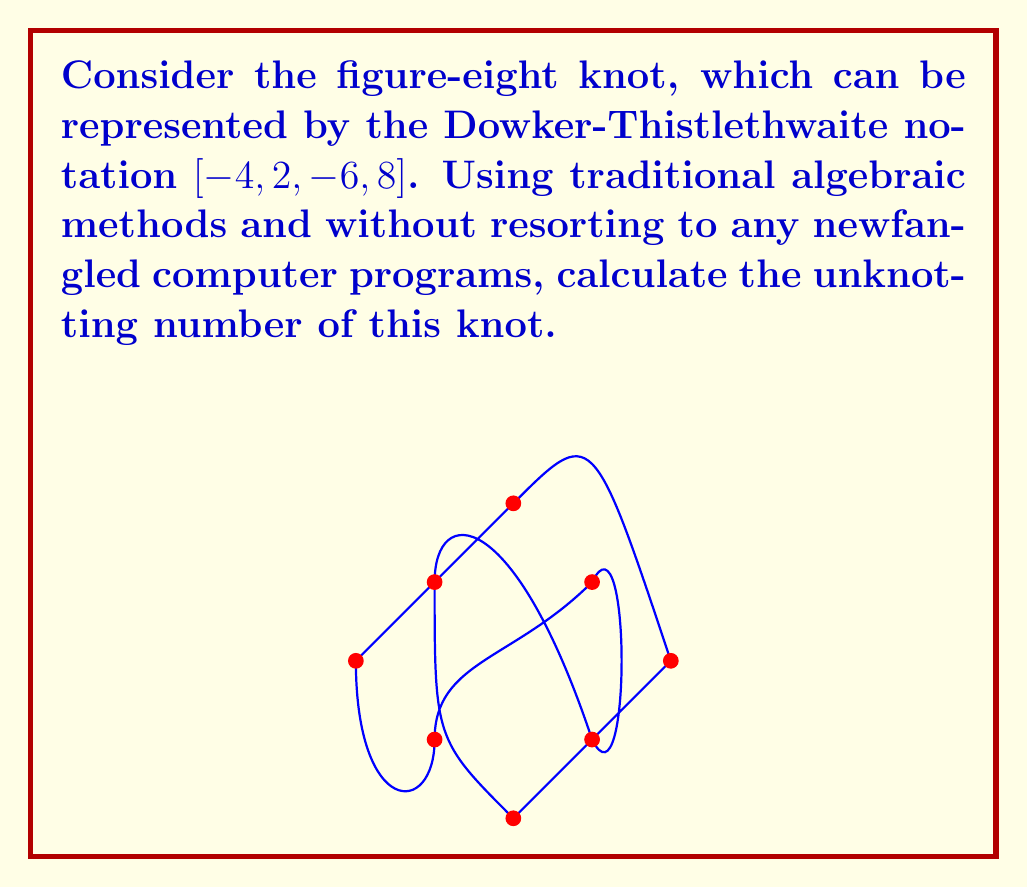Provide a solution to this math problem. To calculate the unknotting number of the figure-eight knot using traditional algebraic methods, we'll follow these steps:

1) First, we need to determine the Alexander polynomial of the knot. For the figure-eight knot, it's given by:

   $$\Delta(t) = t^2 - 3t + 1$$

2) The unknotting number $u(K)$ of a knot $K$ satisfies the following inequality:

   $$|\Delta''(1)| \leq 4u(K)(u(K)-1) + 1$$

   where $\Delta''(1)$ is the second derivative of the Alexander polynomial evaluated at $t=1$.

3) Let's calculate $\Delta''(1)$:
   
   $$\Delta'(t) = 2t - 3$$
   $$\Delta''(t) = 2$$
   $$\Delta''(1) = 2$$

4) Substituting into the inequality:

   $$|2| \leq 4u(K)(u(K)-1) + 1$$
   $$2 \leq 4u^2 - 4u + 1$$
   $$1 \leq 4u^2 - 4u$$
   $$1 \leq 4u(u-1)$$

5) The smallest positive integer $u$ that satisfies this inequality is 1.

6) However, we know that the unknotting number must be at least 1 for any non-trivial knot. To confirm that 1 is indeed the unknotting number, we need to show that a single crossing change can unknot the figure-eight knot.

7) This can be done by changing any one of the crossings in the standard diagram of the figure-eight knot, which will result in the unknot.

Therefore, the unknotting number of the figure-eight knot is 1.
Answer: $1$ 